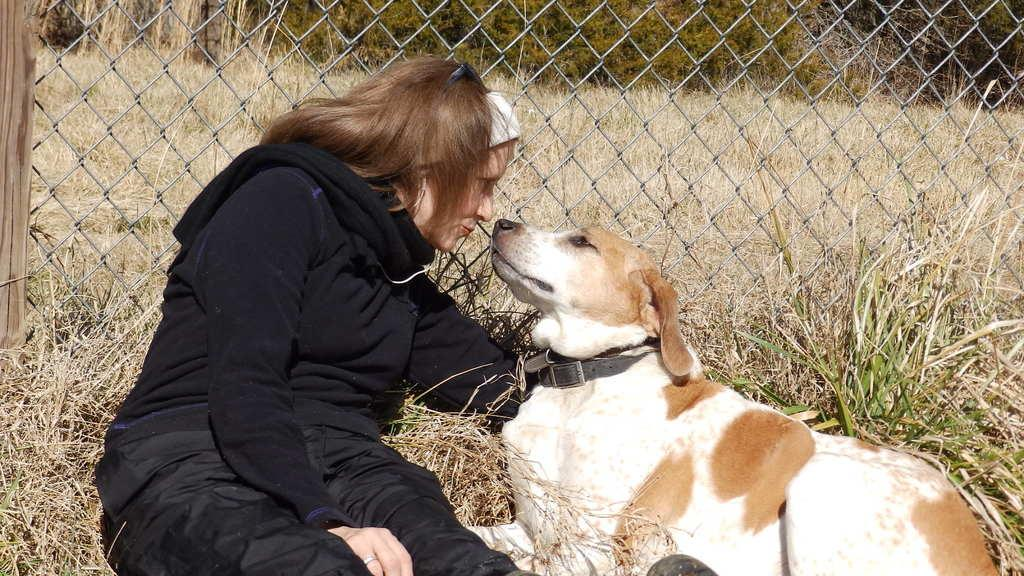What is the main subject of the image? There is a person in the image. What is the person wearing? The person is wearing a black color sweater. What animal can be seen in the image? There is a dog sitting on the floor in the image. What can be seen in the background of the image? There is fencing visible in the background of the image. Is there a stocking hanging from the fencing in the image? There is no stocking visible in the image. Can you see a basketball being played in the image? There is no basketball or any indication of a game being played in the image. 